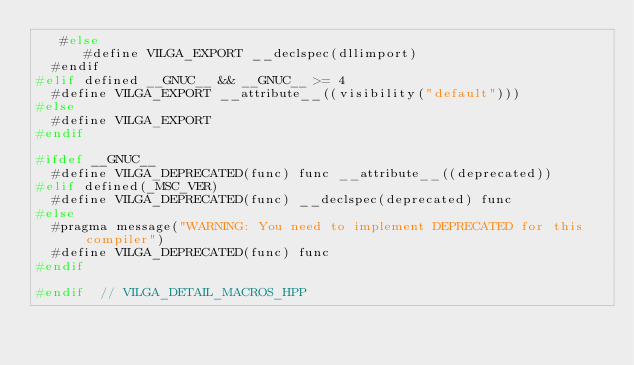Convert code to text. <code><loc_0><loc_0><loc_500><loc_500><_C++_>   #else
      #define VILGA_EXPORT __declspec(dllimport)
  #endif
#elif defined __GNUC__ && __GNUC__ >= 4
  #define VILGA_EXPORT __attribute__((visibility("default")))
#else
  #define VILGA_EXPORT
#endif

#ifdef __GNUC__
  #define VILGA_DEPRECATED(func) func __attribute__((deprecated))
#elif defined(_MSC_VER)
  #define VILGA_DEPRECATED(func) __declspec(deprecated) func
#else
  #pragma message("WARNING: You need to implement DEPRECATED for this compiler")
  #define VILGA_DEPRECATED(func) func
#endif

#endif  // VILGA_DETAIL_MACROS_HPP
</code> 